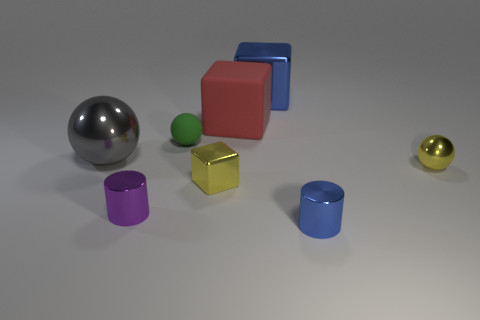Subtract all tiny yellow shiny cubes. How many cubes are left? 2 Subtract all purple cylinders. How many cylinders are left? 1 Subtract 2 cubes. How many cubes are left? 1 Add 1 metallic cubes. How many objects exist? 9 Subtract 1 yellow blocks. How many objects are left? 7 Subtract all spheres. How many objects are left? 5 Subtract all blue cubes. Subtract all cyan spheres. How many cubes are left? 2 Subtract all gray balls. How many purple cylinders are left? 1 Subtract all large blue metal objects. Subtract all yellow shiny things. How many objects are left? 5 Add 2 big red cubes. How many big red cubes are left? 3 